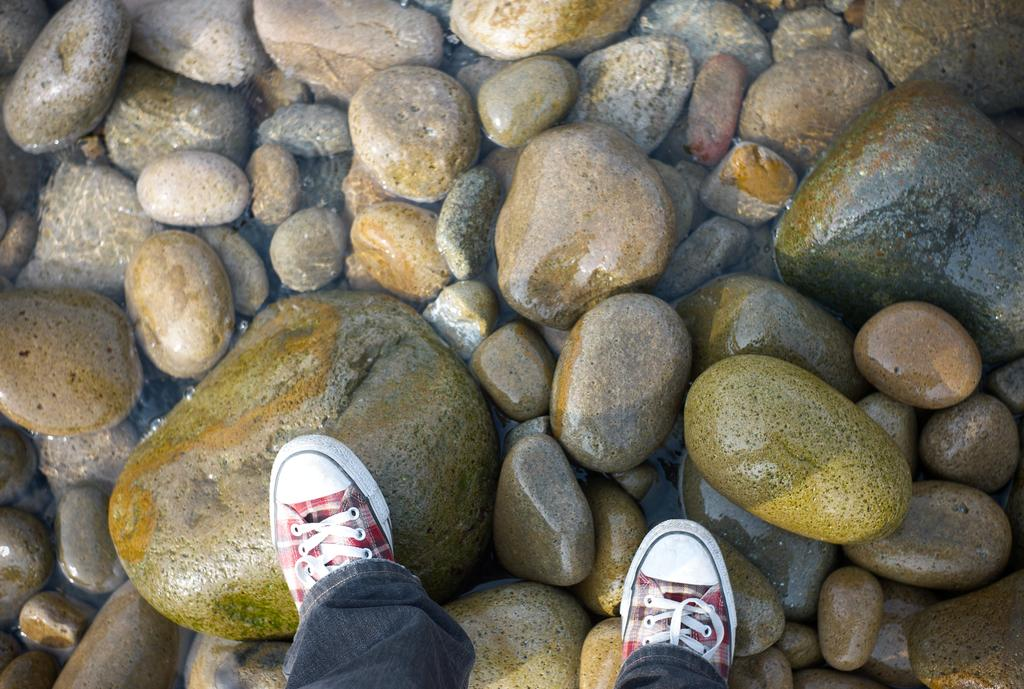What part of a person can be seen in the image? There are legs of a person visible in the image. What type of footwear is the person wearing? The person is wearing shoes. What is the surface the legs are standing on? The legs are on stones. What natural element is present in the image? There is water in the image. What type of card is floating in the water in the image? There is no card present in the image; it only features legs of a person standing on stones with water nearby. 